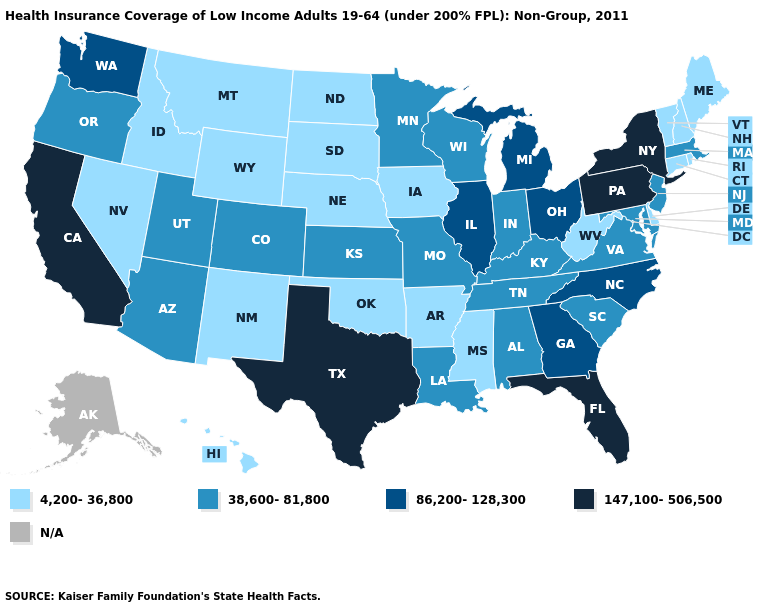Does North Carolina have the highest value in the USA?
Short answer required. No. Which states have the lowest value in the USA?
Quick response, please. Arkansas, Connecticut, Delaware, Hawaii, Idaho, Iowa, Maine, Mississippi, Montana, Nebraska, Nevada, New Hampshire, New Mexico, North Dakota, Oklahoma, Rhode Island, South Dakota, Vermont, West Virginia, Wyoming. Name the states that have a value in the range 38,600-81,800?
Give a very brief answer. Alabama, Arizona, Colorado, Indiana, Kansas, Kentucky, Louisiana, Maryland, Massachusetts, Minnesota, Missouri, New Jersey, Oregon, South Carolina, Tennessee, Utah, Virginia, Wisconsin. Name the states that have a value in the range N/A?
Quick response, please. Alaska. What is the lowest value in the South?
Answer briefly. 4,200-36,800. What is the lowest value in states that border South Carolina?
Short answer required. 86,200-128,300. Name the states that have a value in the range 147,100-506,500?
Answer briefly. California, Florida, New York, Pennsylvania, Texas. What is the highest value in the USA?
Concise answer only. 147,100-506,500. Name the states that have a value in the range 147,100-506,500?
Short answer required. California, Florida, New York, Pennsylvania, Texas. Does the map have missing data?
Be succinct. Yes. Does Mississippi have the highest value in the South?
Give a very brief answer. No. What is the highest value in the West ?
Short answer required. 147,100-506,500. What is the value of Texas?
Write a very short answer. 147,100-506,500. What is the highest value in states that border Indiana?
Write a very short answer. 86,200-128,300. What is the highest value in states that border Minnesota?
Short answer required. 38,600-81,800. 